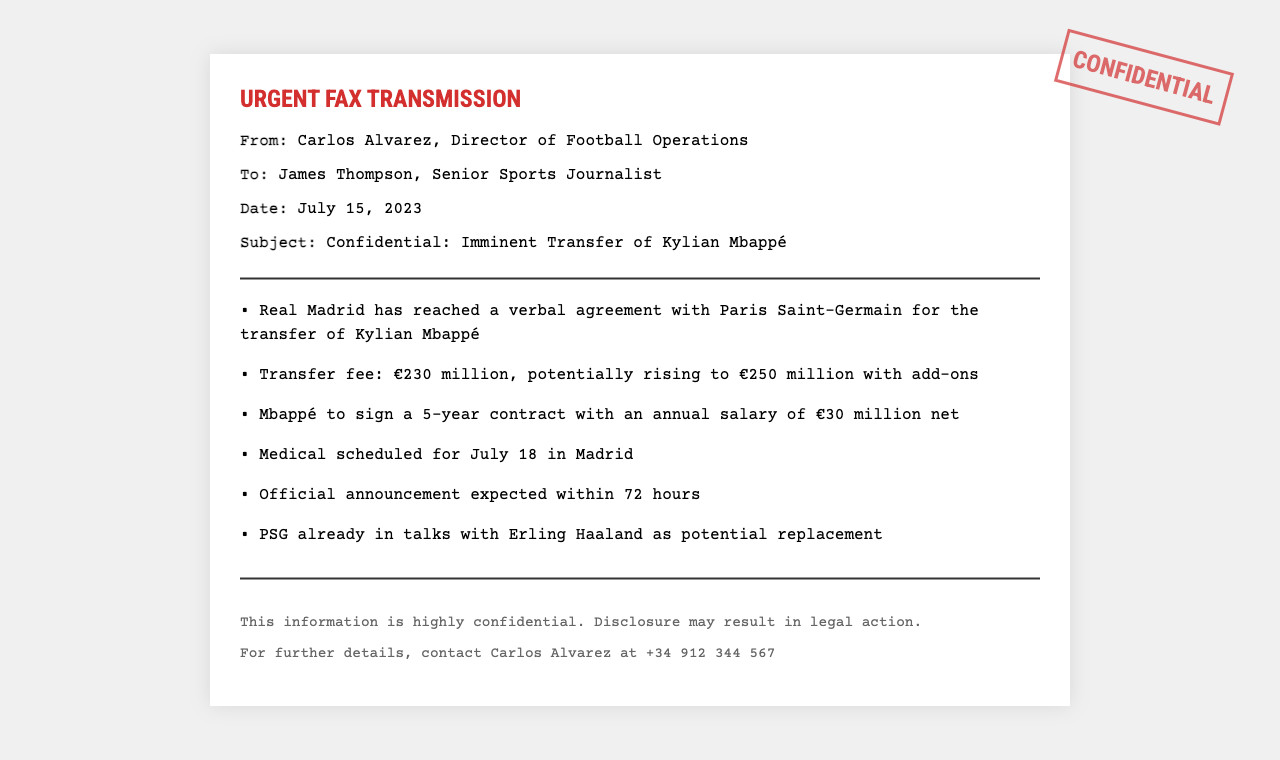What is the sender's name? The sender's name is mentioned as Carlos Alvarez in the document.
Answer: Carlos Alvarez What is the date of the fax? The date of the fax is indicated clearly in the document, which is July 15, 2023.
Answer: July 15, 2023 Who is the recipient of the fax? The recipient of the fax is identified as James Thompson in the document.
Answer: James Thompson What is the transfer fee for Kylian Mbappé? The transfer fee is listed in the document as €230 million, potentially rising to €250 million with add-ons.
Answer: €230 million When is the medical scheduled? The document states that the medical is scheduled for July 18 in Madrid.
Answer: July 18 What is Kylian Mbappé's annual salary? The document specifies that Mbappé's annual salary is €30 million net.
Answer: €30 million Which club is in talks with Erling Haaland? The document mentions that Paris Saint-Germain is in talks with Erling Haaland.
Answer: Paris Saint-Germain What is the expected time frame for the official announcement? The estimated time frame for the official announcement is mentioned as within 72 hours.
Answer: 72 hours What type of document is this? The document is identified as an "Urgent Fax Transmission” which is indicated in the title and layout.
Answer: Urgent Fax Transmission 